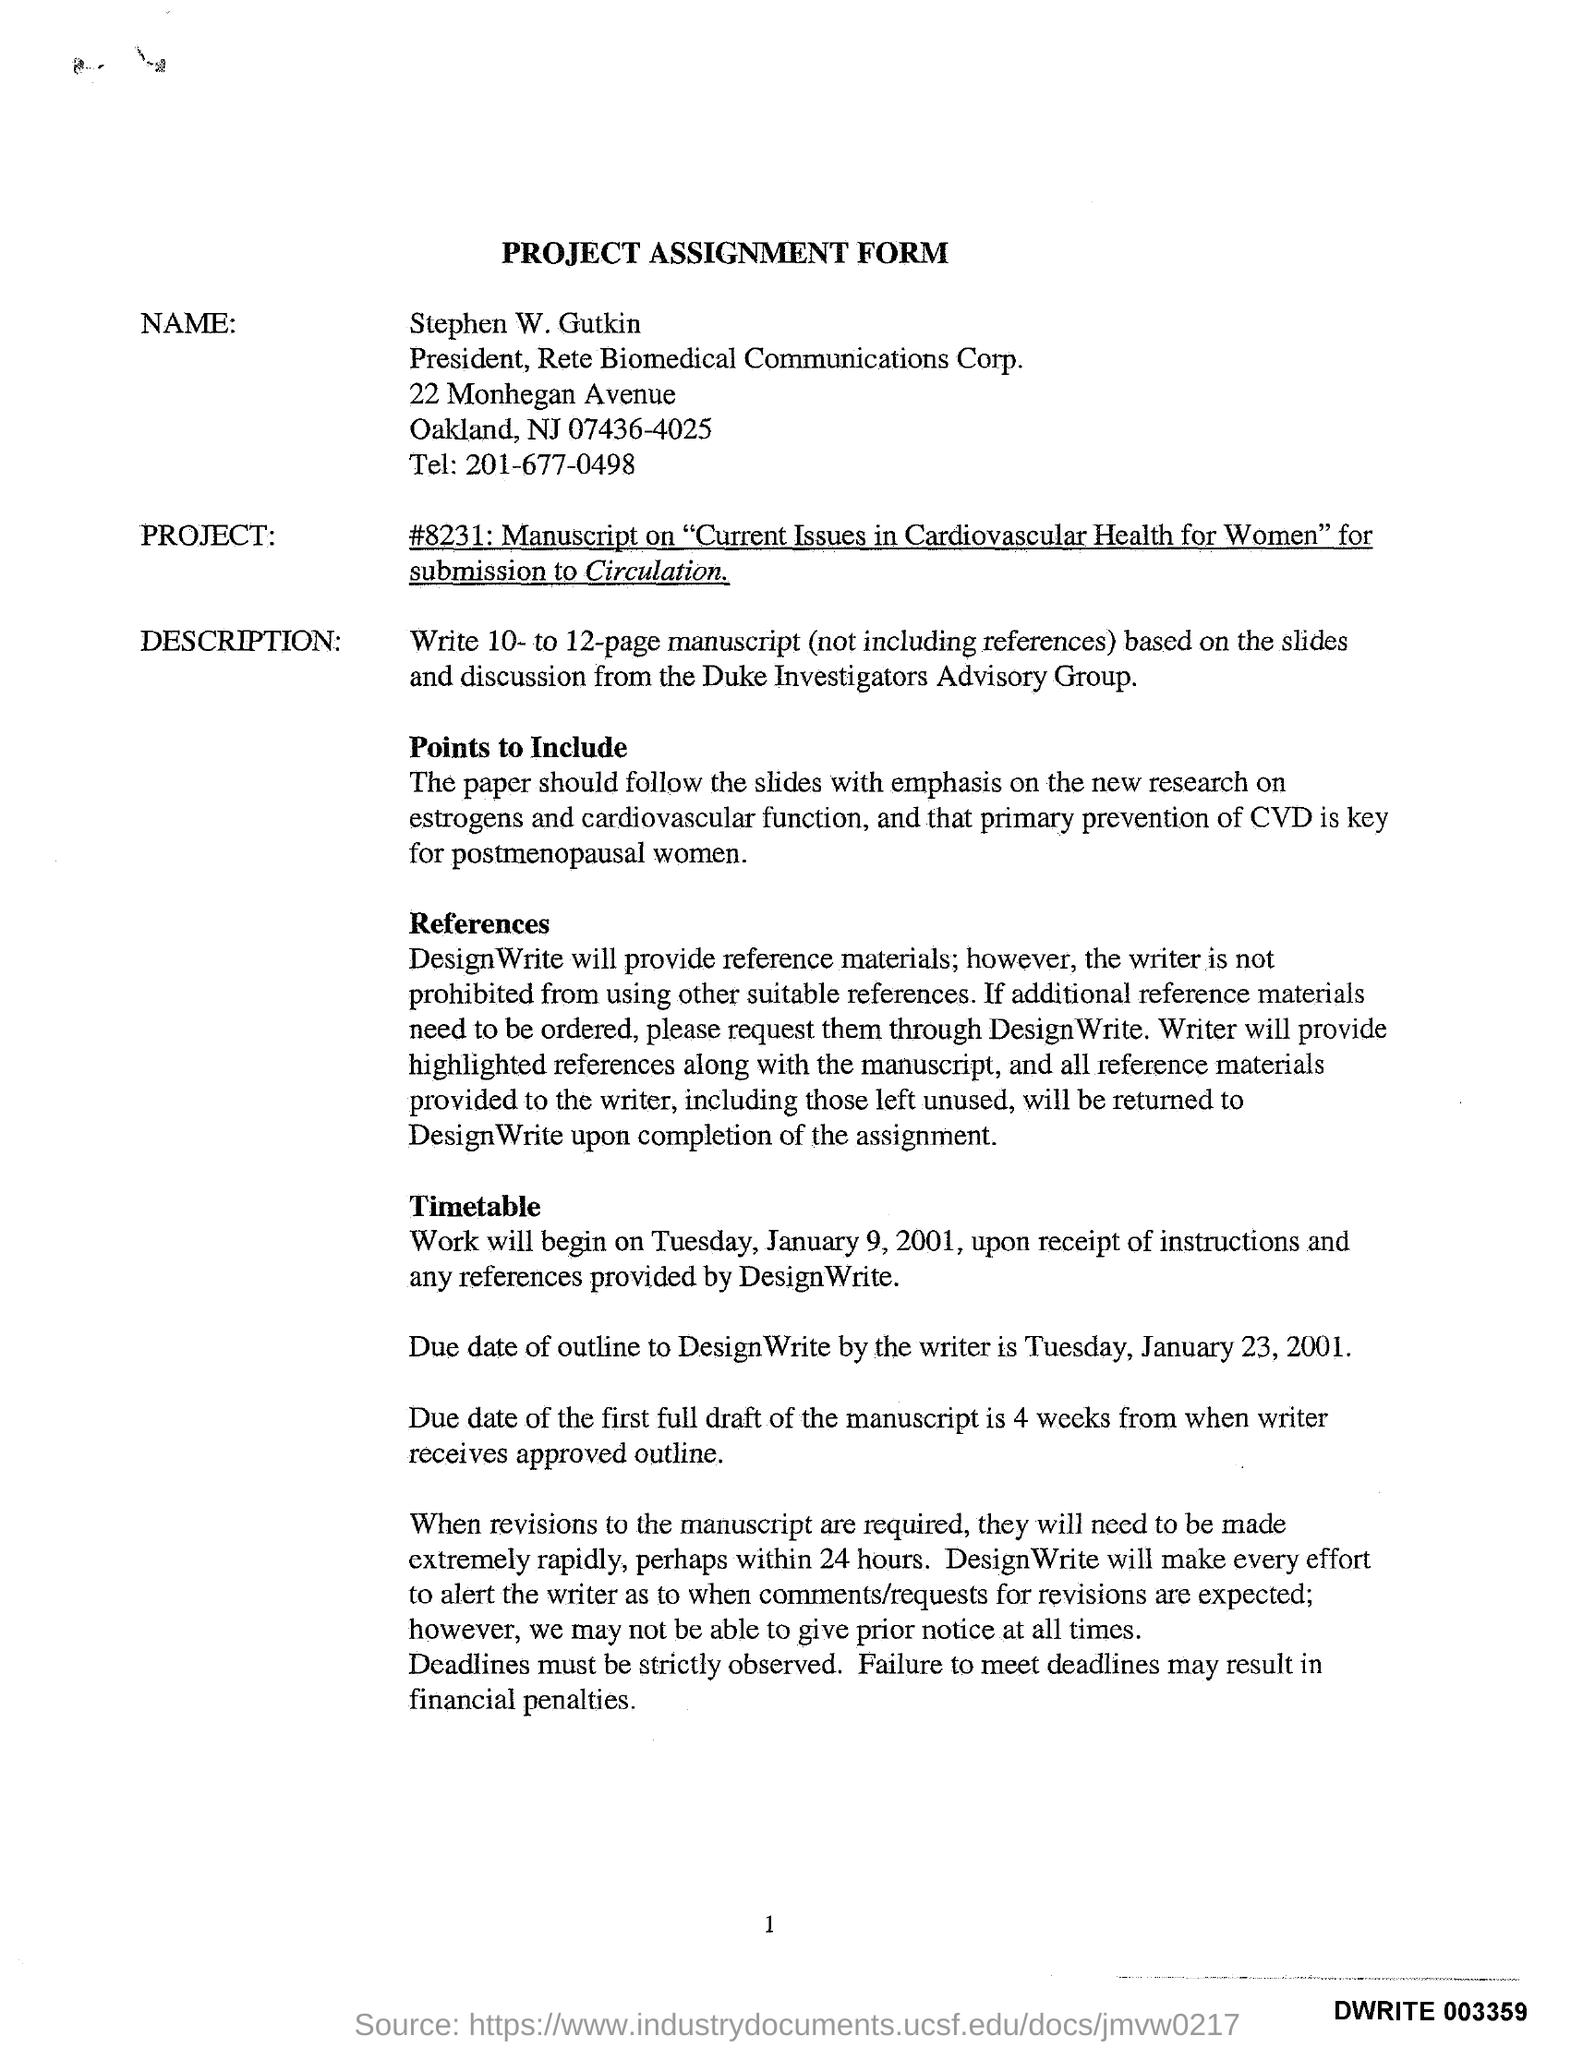WHO'S NAME WAS WRITTEN IN THE PROJECT ASSIGNMENT FORM ?
Ensure brevity in your answer.  Stephen W. Gutkin. What is the tel number given in the assignment form ?
Offer a very short reply. 201-677-0498. What is the due date of outline mentioned in the assignment form ?
Your answer should be very brief. January 23, 2001. What is the due date of the first full draft of the manuscript ?
Your response must be concise. 4 weeks. What may be the result if failure meet deadlines ?
Ensure brevity in your answer.  Financial penalties. 